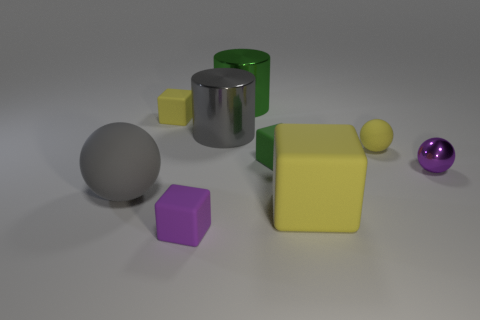Subtract all rubber balls. How many balls are left? 1 Add 1 rubber spheres. How many objects exist? 10 Subtract 1 cylinders. How many cylinders are left? 1 Subtract all purple blocks. How many blocks are left? 3 Subtract all balls. How many objects are left? 6 Add 6 large metallic things. How many large metallic things are left? 8 Add 3 cylinders. How many cylinders exist? 5 Subtract 0 red balls. How many objects are left? 9 Subtract all cyan cylinders. Subtract all brown balls. How many cylinders are left? 2 Subtract all brown cylinders. How many purple balls are left? 1 